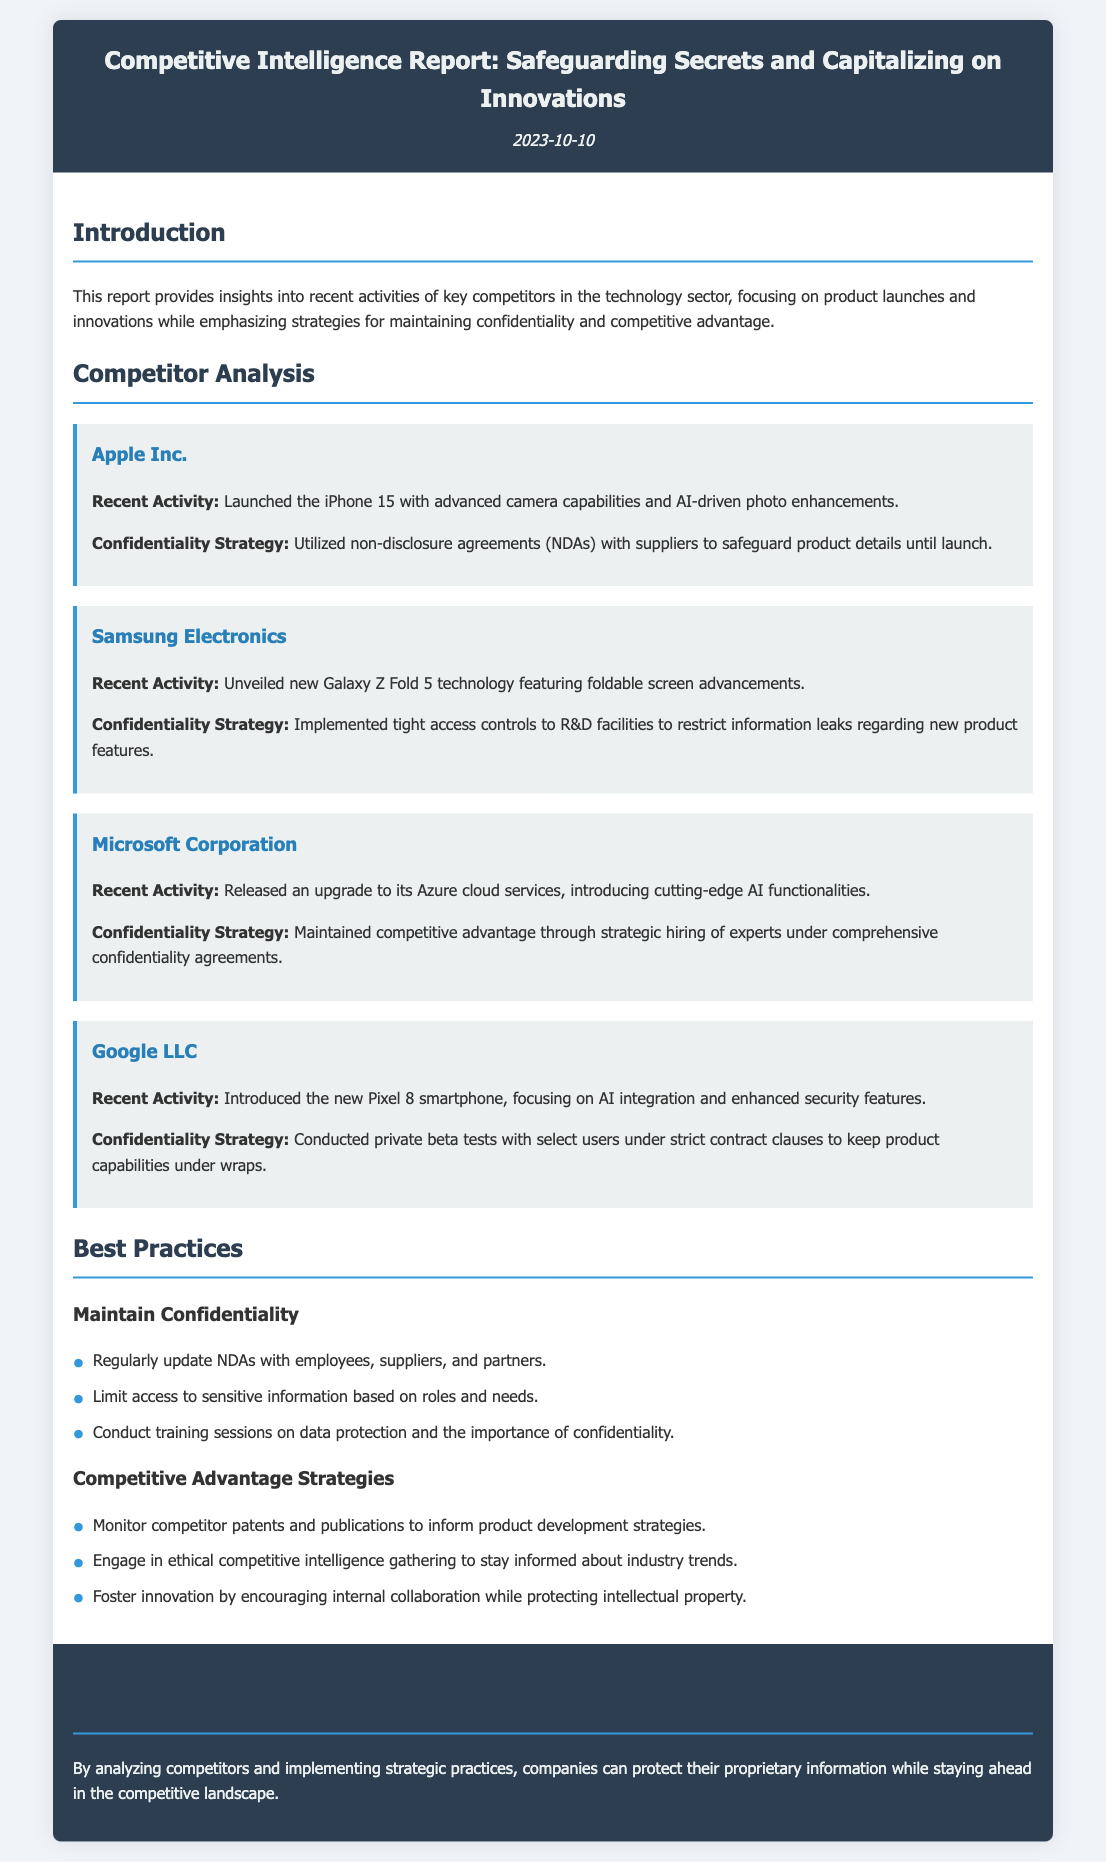What is the date of the report? The date of the report is specified in the header section of the document.
Answer: 2023-10-10 Which company launched the iPhone 15? The document mentions Apple Inc. as the company that launched the iPhone 15.
Answer: Apple Inc What confidentiality strategy did Samsung Electronics use? The document states that Samsung implemented tight access controls to R&D facilities.
Answer: Tight access controls Which competitor introduced the new Pixel 8 smartphone? The document lists Google LLC as the competitor that introduced the Pixel 8 smartphone.
Answer: Google LLC What is a recommended best practice for maintaining confidentiality? The document lists the recommendation to regularly update NDAs with employees, suppliers, and partners as a best practice.
Answer: Regularly update NDAs How does Microsoft maintain its competitive advantage? The report explains that Microsoft strategically hires experts under comprehensive confidentiality agreements.
Answer: Strategic hiring What type of report is being discussed? The title of the document indicates that it is a Competitive Intelligence Report.
Answer: Competitive Intelligence Report What recent activity is associated with Apple Inc.? According to the document, Apple Inc. launched the iPhone 15 with advanced camera capabilities.
Answer: Launched the iPhone 15 What is the focus of this Competitive Intelligence Report? The introduction section outlines that the report focuses on competitor activities, product launches, and innovations.
Answer: Competitor activities, product launches, and innovations 